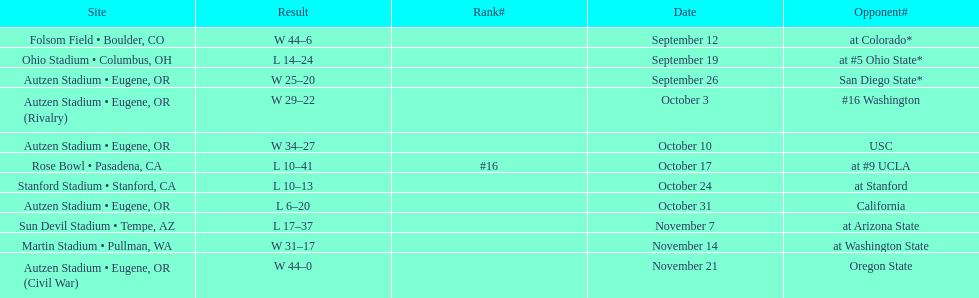Did the team win or lose more games? Win. 